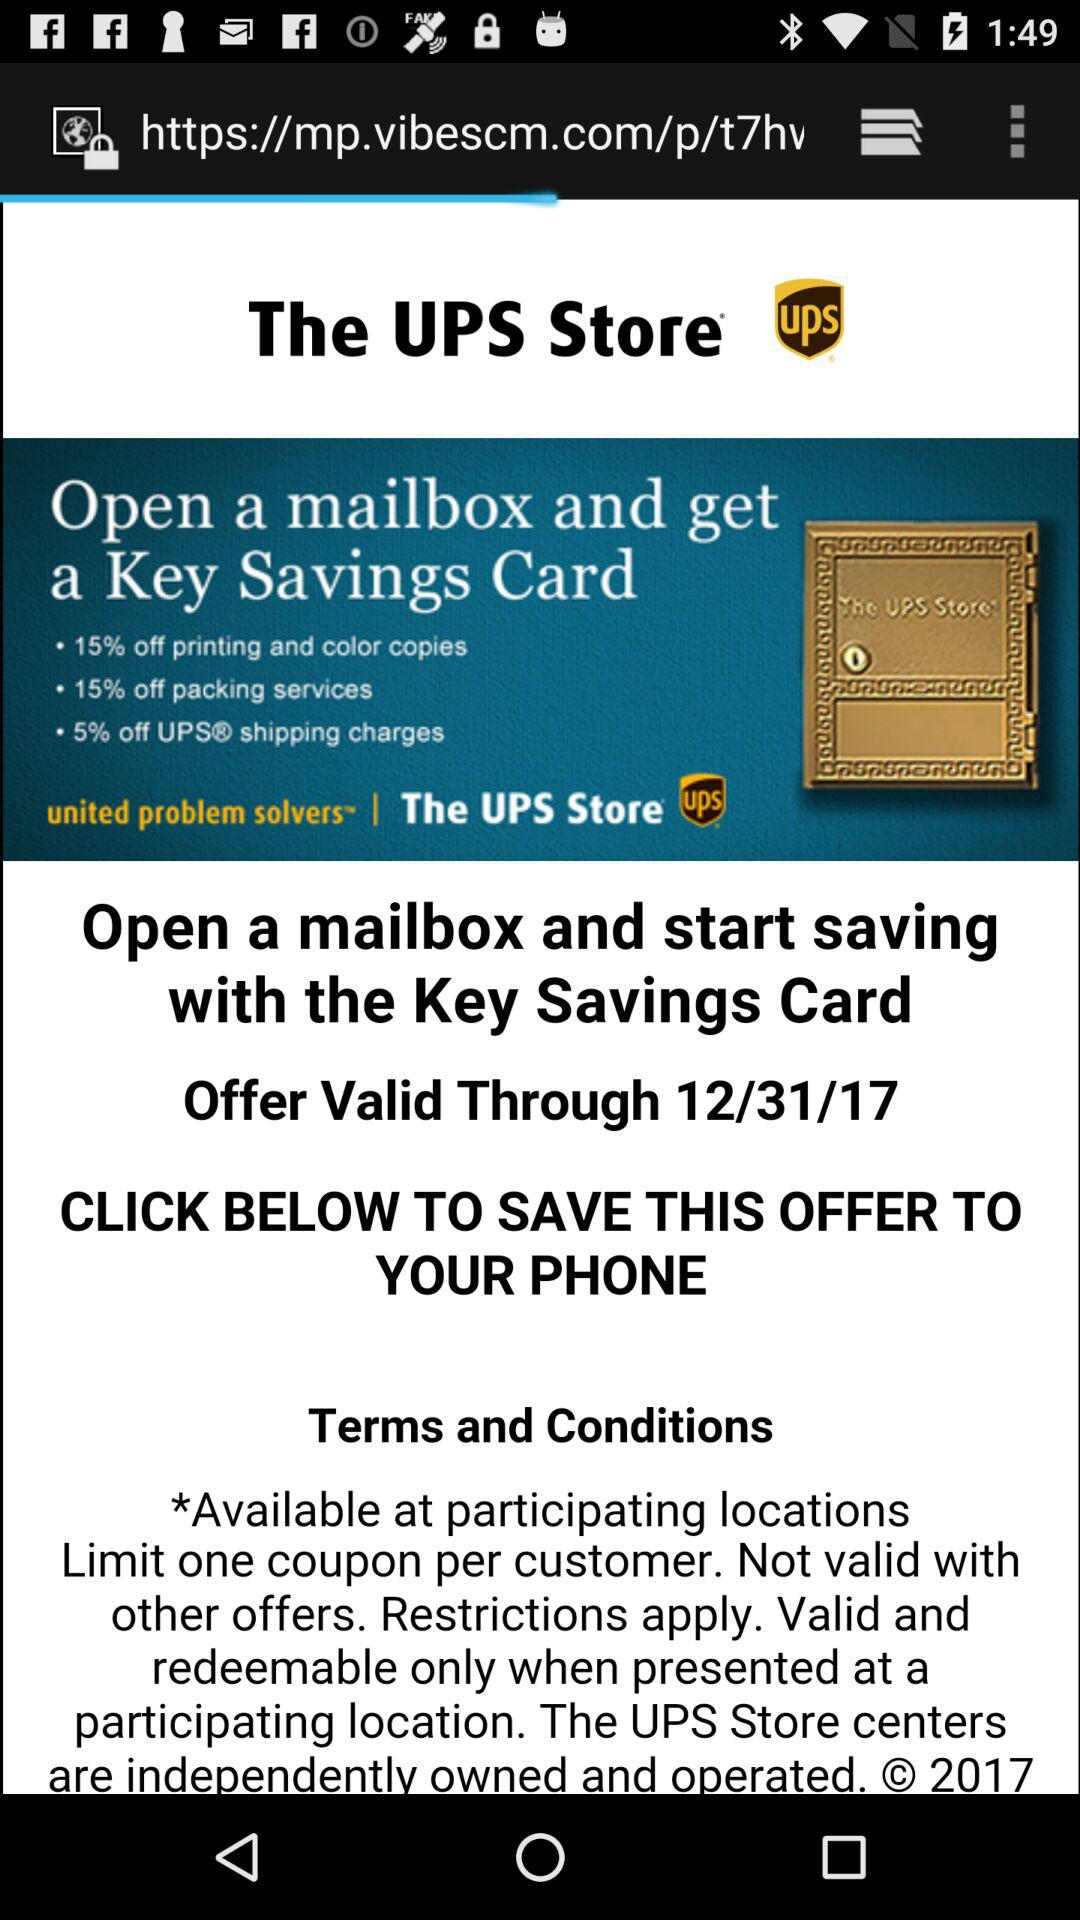How many more percentage off offers are there for shipping than printing and color copies?
Answer the question using a single word or phrase. 10 